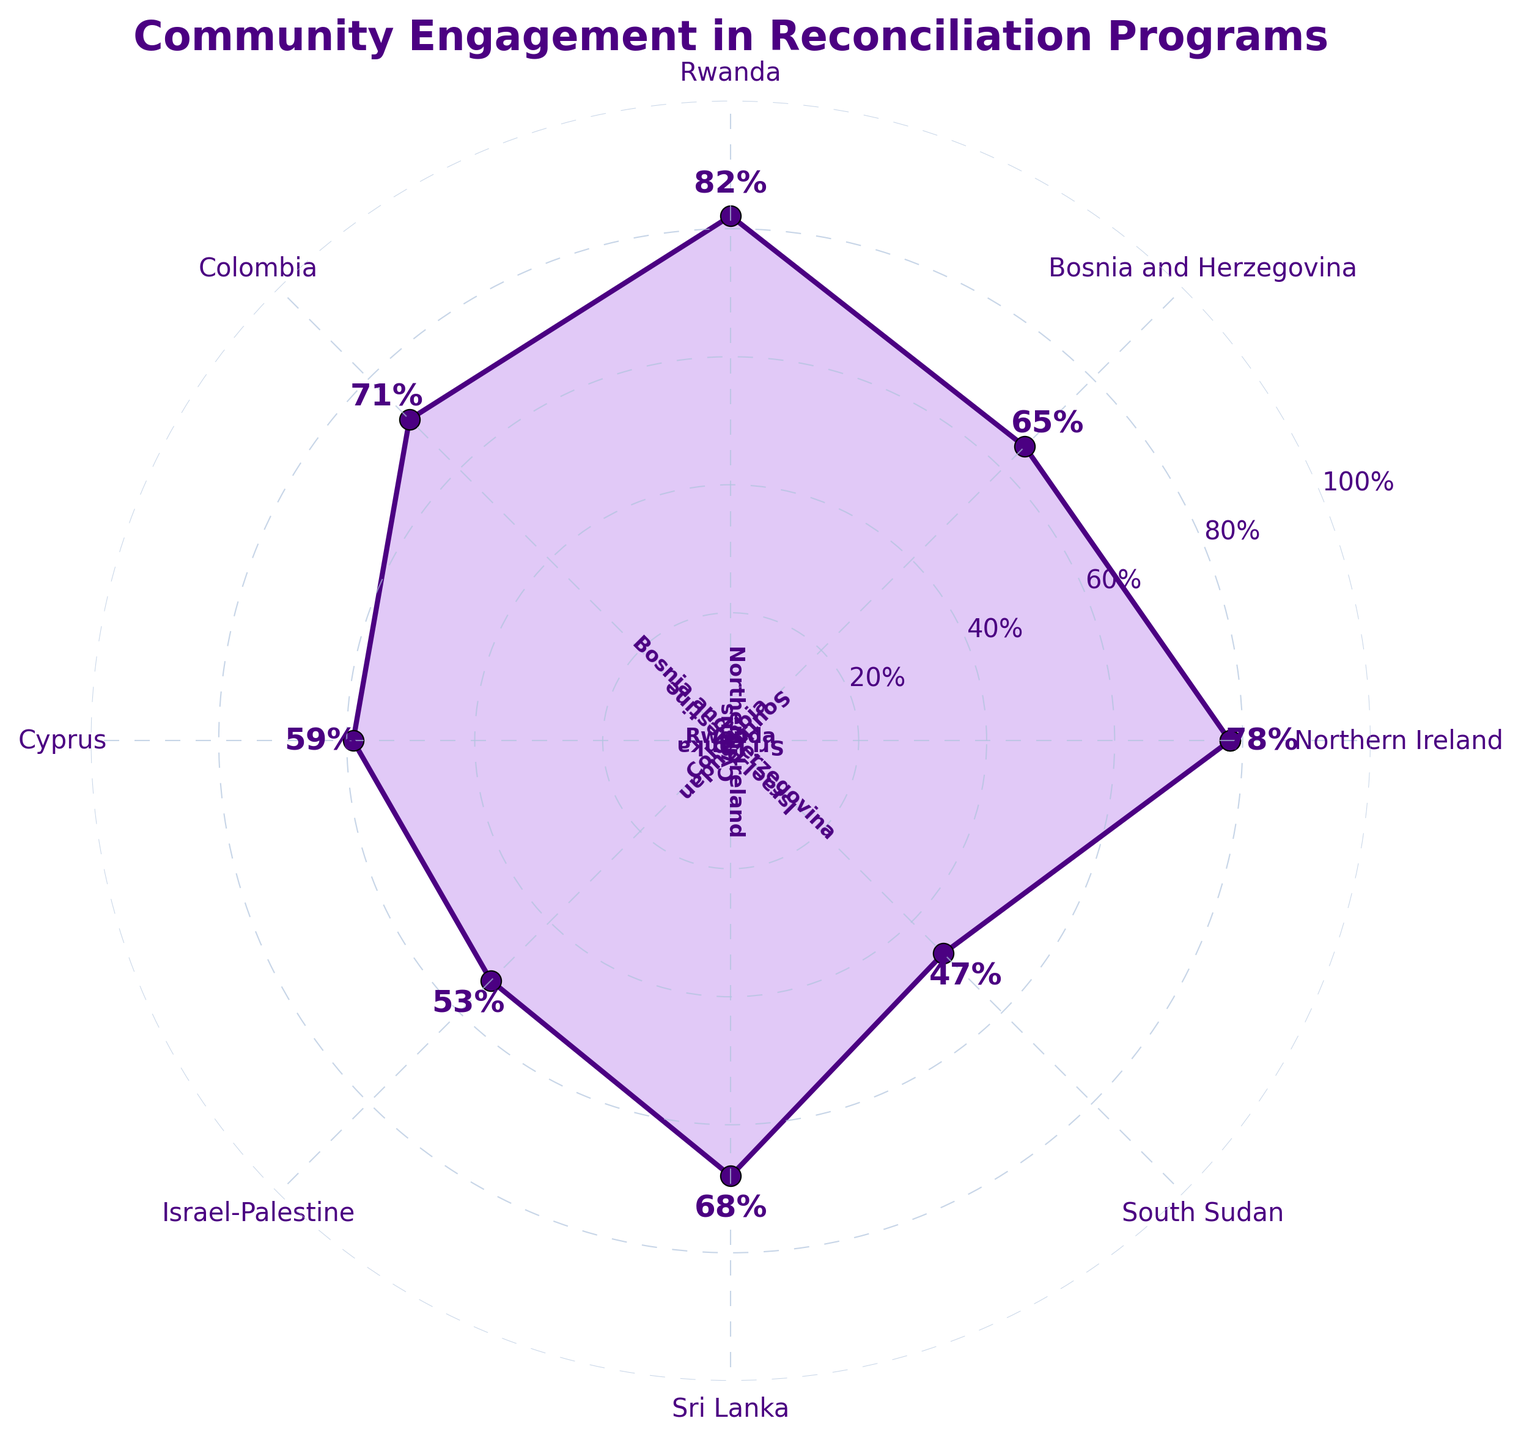Which region has the highest level of community engagement? To find the region with the highest engagement level, look at the radially-oriented points on the chart. The region with a value of 82% is Rwanda, the highest among all plotted values.
Answer: Rwanda What is the engagement level in South Sudan? Refer to the figure and locate South Sudan. The engagement level point for South Sudan corresponds to the value of 47%.
Answer: 47% How many regions have an engagement level above 70%? Identify the regions with an engagement level higher than 70%. Rwanda (82%), Northern Ireland (78%), and Colombia (71%) are the regions fitting this criterion. Hence, there are 3 regions.
Answer: 3 Which region has the lowest engagement level? Locate the region with the smallest value on the figure. South Sudan has the lowest engagement level at 47%.
Answer: South Sudan What is the average engagement level across all the regions? Add up all the engagement levels and divide by the number of regions: (78+65+82+71+59+53+68+47)/8 = 523/8. The average engagement level is 65.375.
Answer: 65.375 How much higher is Rwanda's engagement level compared to Cyprus'? Rwanda's engagement level is 82% while Cyprus' is 59%. The difference is calculated as 82 - 59 = 23%.
Answer: 23% Is Bosnia and Herzegovina's engagement level closer to that of Colombia or Cyprus? Bosnia and Herzegovina has an engagement level of 65%. Compare this to Colombia's 71% and Cyprus' 59%. The differences are 71 - 65 = 6% and 65 - 59 = 6%. Thus, it's equally close to both.
Answer: Equally to both Which region is closest to the average engagement level? First, calculate the average (65.375). Then find the region closest to this value: 65 (Bosnia and Herzegovina), 68 (Sri Lanka), among others. Bosnia and Herzegovina (65%) is the closest.
Answer: Bosnia and Herzegovina Which regions have an engagement level below 50%? Identify the regions with engagement levels under 50% from the chart. South Sudan has an engagement level of 47%, the only region below this threshold.
Answer: South Sudan What's the range of engagement levels across all regions? Determine the highest and lowest values on the chart, which are 82% (Rwanda) and 47% (South Sudan), respectively. The range is calculated as 82 - 47 = 35%.
Answer: 35% 